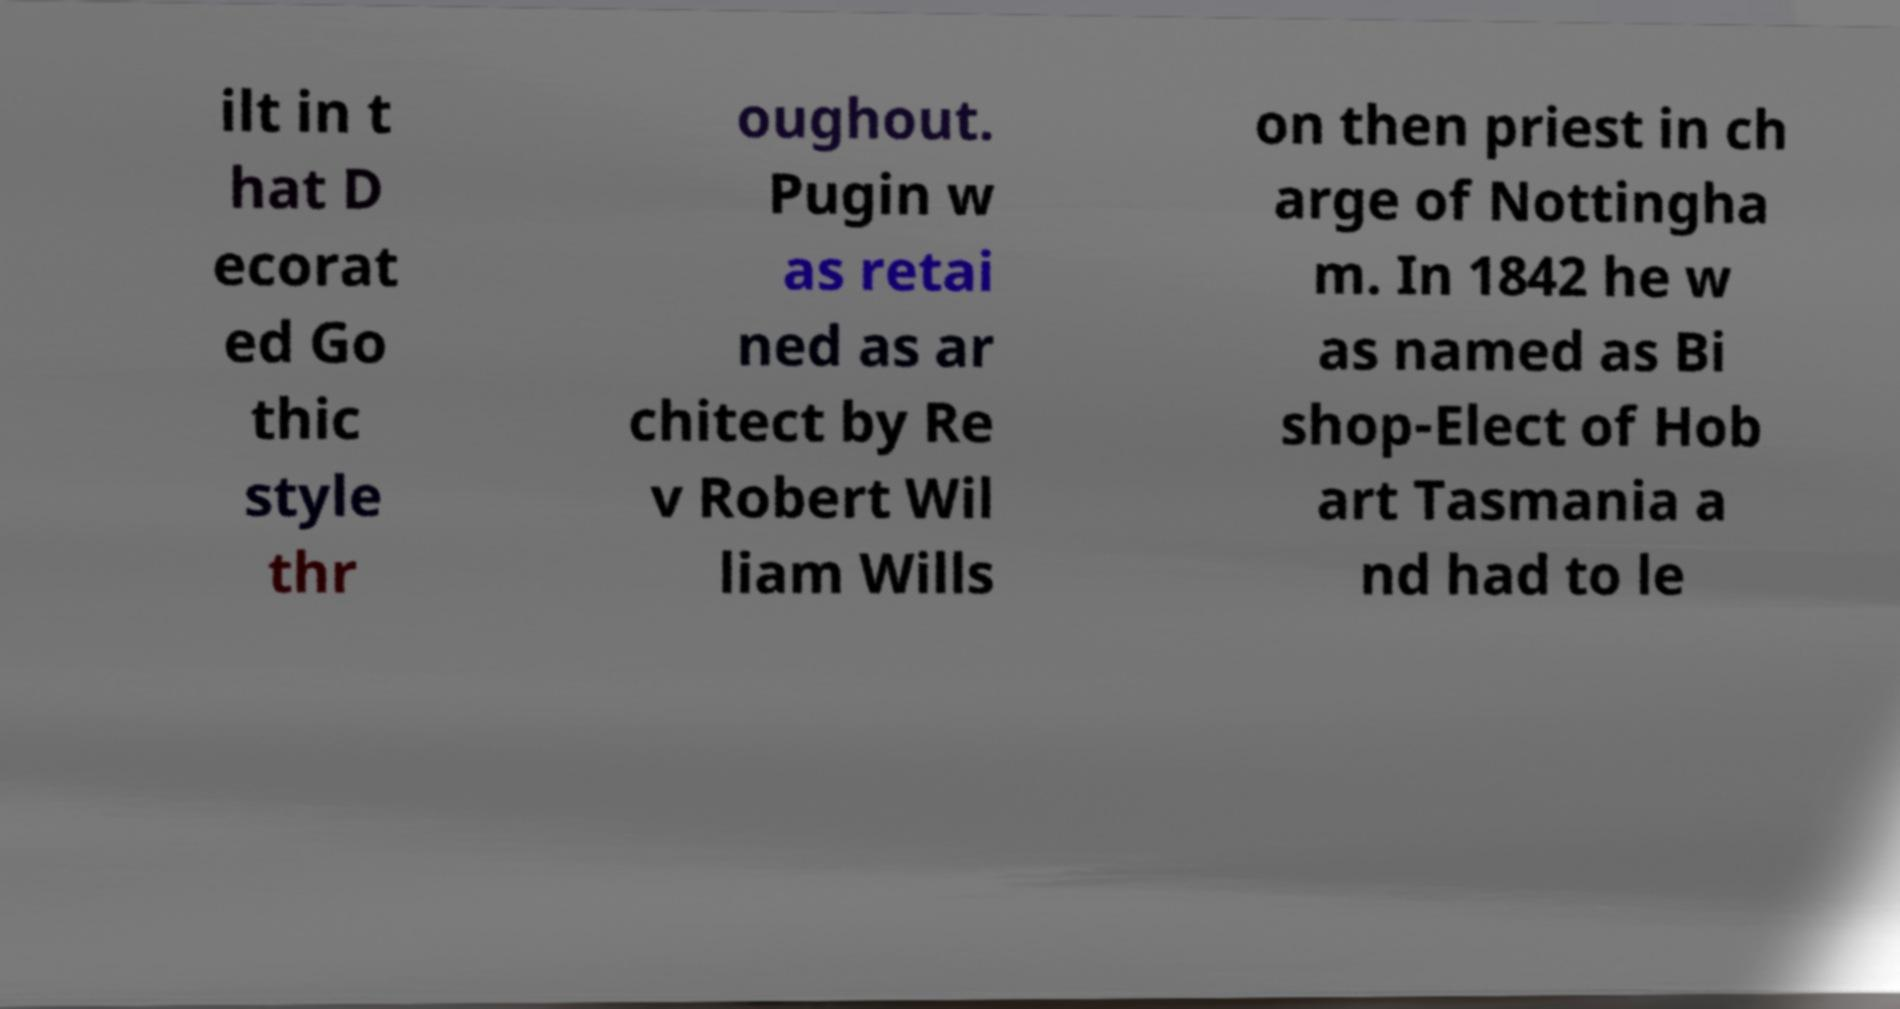For documentation purposes, I need the text within this image transcribed. Could you provide that? ilt in t hat D ecorat ed Go thic style thr oughout. Pugin w as retai ned as ar chitect by Re v Robert Wil liam Wills on then priest in ch arge of Nottingha m. In 1842 he w as named as Bi shop-Elect of Hob art Tasmania a nd had to le 